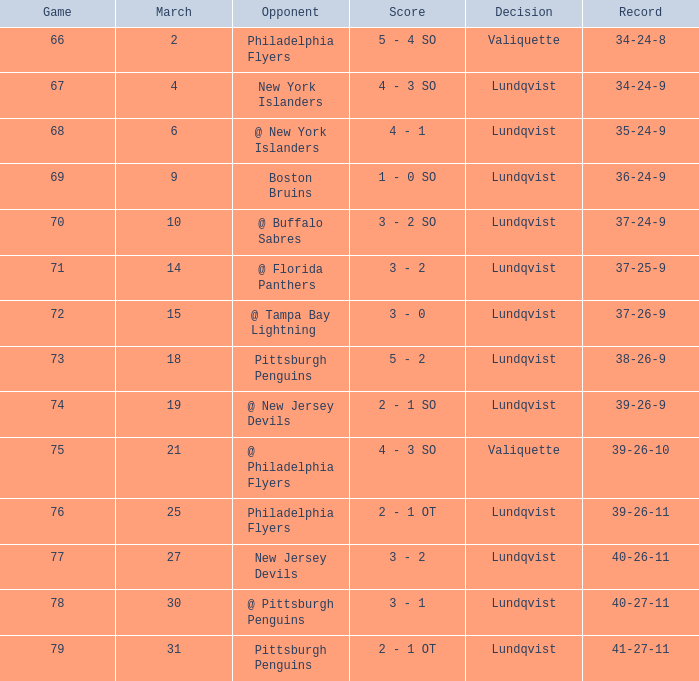Which adversary's score was below 76 when the march was 10? @ Buffalo Sabres. 